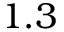<formula> <loc_0><loc_0><loc_500><loc_500>1 . 3</formula> 